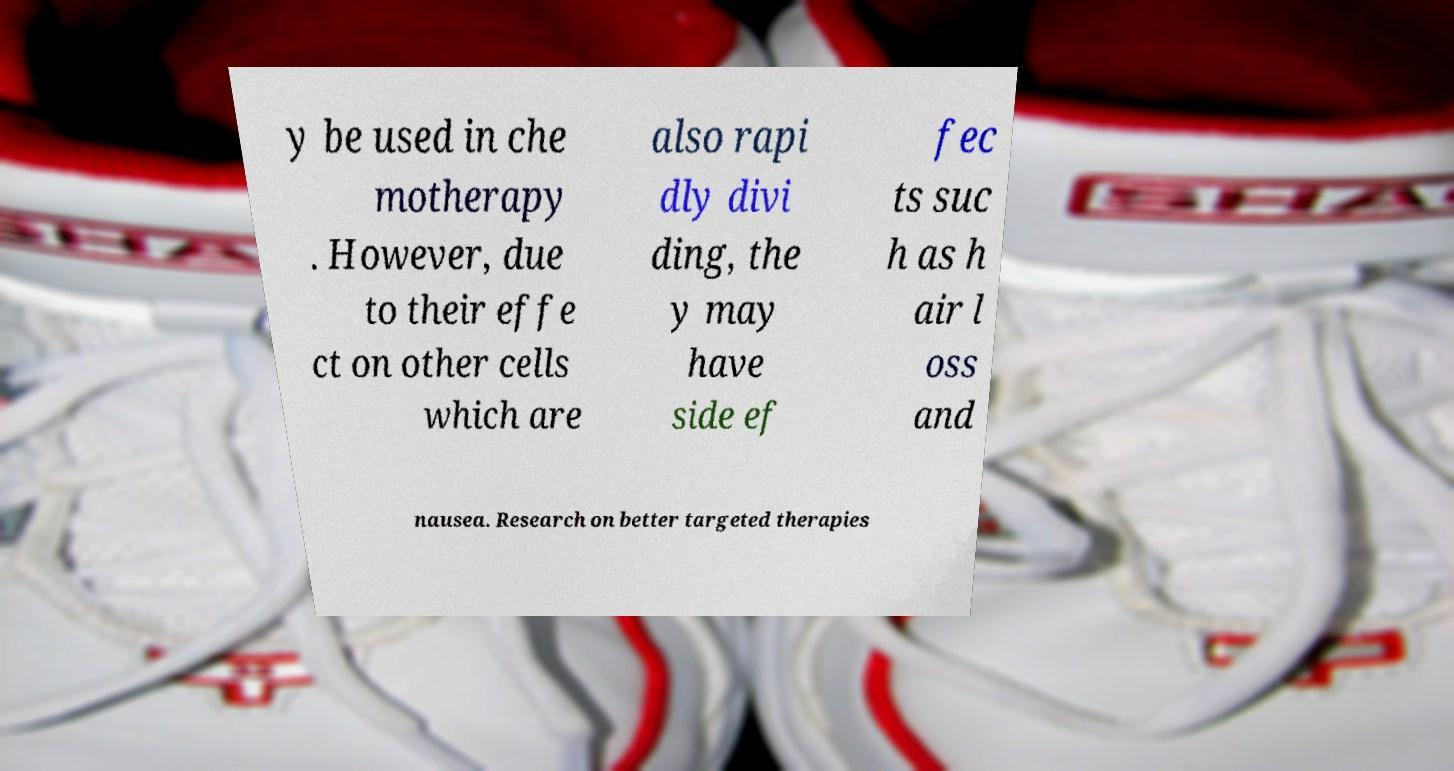There's text embedded in this image that I need extracted. Can you transcribe it verbatim? y be used in che motherapy . However, due to their effe ct on other cells which are also rapi dly divi ding, the y may have side ef fec ts suc h as h air l oss and nausea. Research on better targeted therapies 